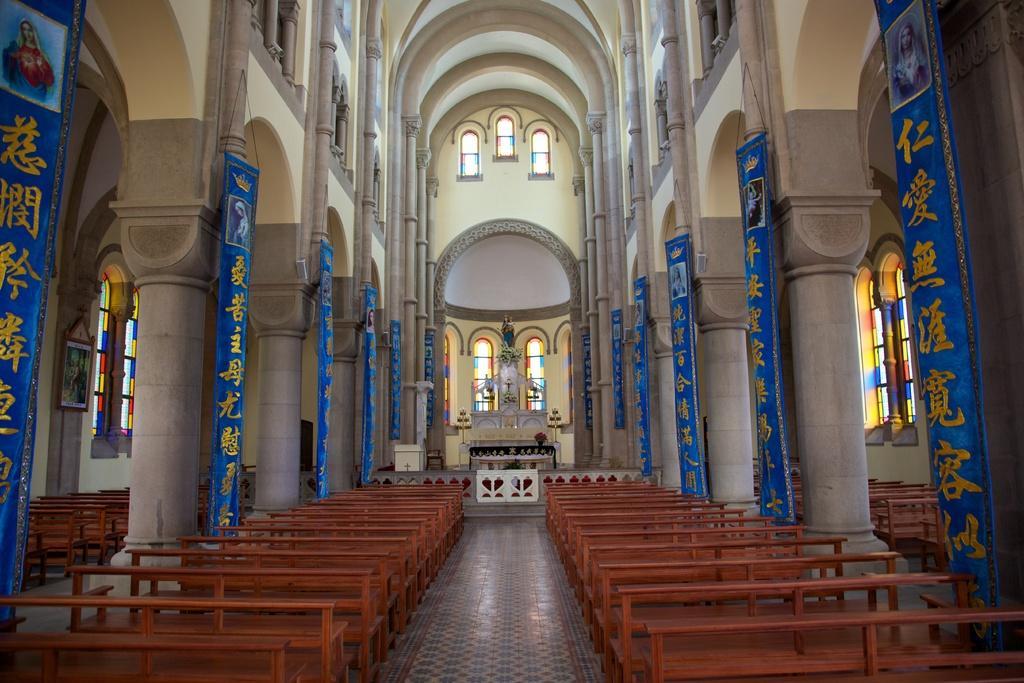Could you give a brief overview of what you see in this image? In the picture we can see an interior of the church building with two rows of benches and in the background, we can see a cross near it, we can see flower decorations and besides we can see some pillars and on the floor we can see a mat. 